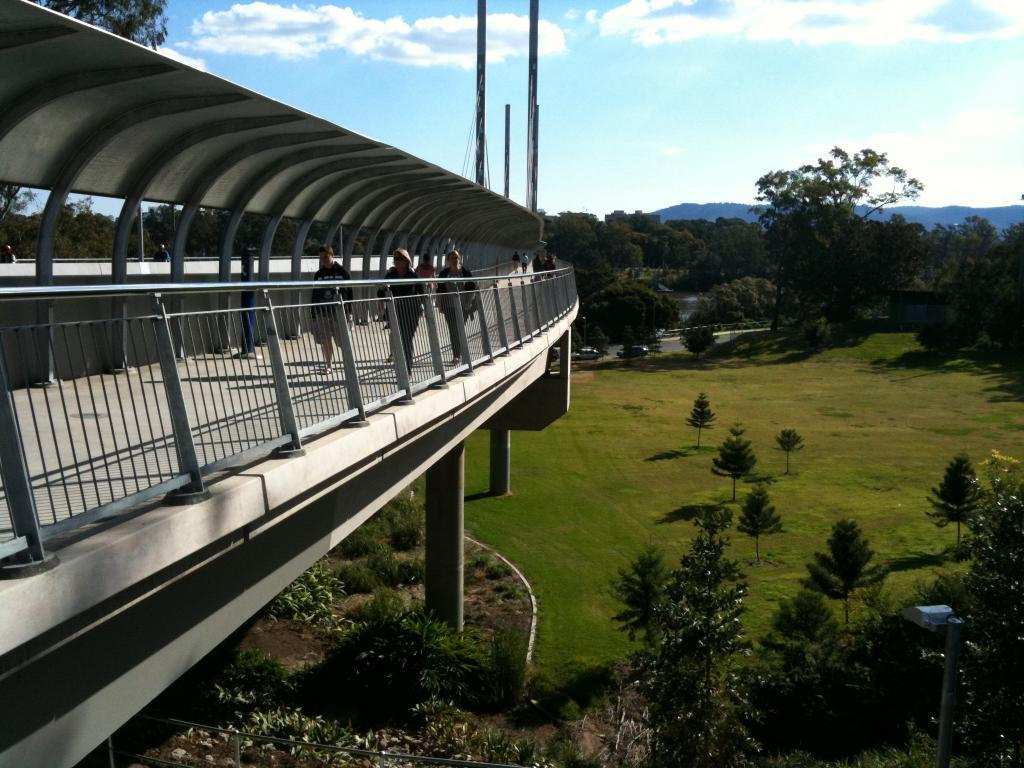What type of vegetation can be seen in the image? There are many trees in the image. What structure is present in the image? There is a bridge in the image. What type of ground cover is present in the image? The area is planted with grass. What architectural elements can be seen in the image? There are pillars and poles in the image. What is visible in the background of the image? The sky is visible in the background. What activity can be observed in the image? There are people walking through a walkway in the image. What type of question is being asked in the image? There is no question being asked in the image; it is a visual representation of a scene with trees, a bridge, grass, pillars, poles, the sky, and people walking through a walkway. What role does the cork play in the image? There is no cork present in the image. 